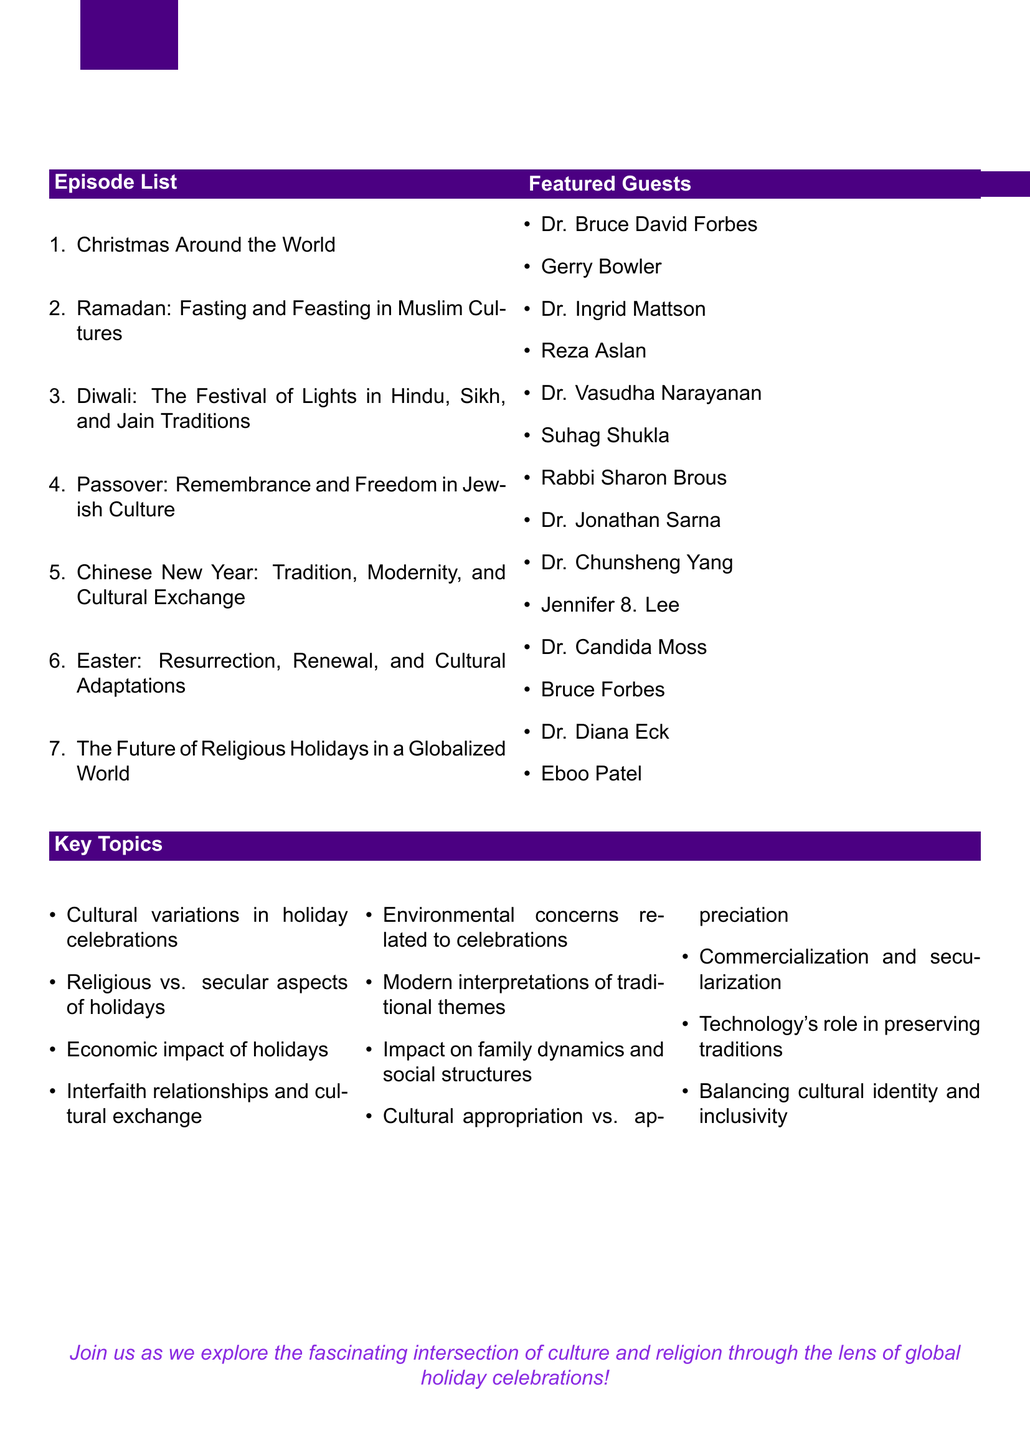What is the title of the series? The title of the series is explicitly stated at the beginning of the document.
Answer: Sacred Celebrations: The Global Impact of Religious Holidays Who is the first potential guest for the episode "Christmas Around the World"? The potential guests for each episode are listed, and the first guest for this episode is mentioned.
Answer: Dr. Bruce David Forbes How many episodes are listed in the document? The document includes an itemized list of episodes, which can be counted.
Answer: 7 What is a key topic covered in the series? The document lists several key topics relevant to the series.
Answer: Cultural variations in holiday celebrations What is the title of the concluding episode? The title of the concluding episode is clearly provided in the outline.
Answer: The Future of Religious Holidays in a Globalized World Which holiday is associated with fasting and feasting in Muslim cultures? The outlined episodes are identified by their specific religious holiday focus, this one is directly related to Ramadan.
Answer: Ramadan Who authored "Christmas in the Crosshairs"? The document provides a list of potential guests, including authors and their works.
Answer: Gerry Bowler What is the focus of the episode titled "Passover"? The outline for each episode gives a clear indication of its topic, specifically for this episode.
Answer: Remembrance and Freedom in Jewish Culture 